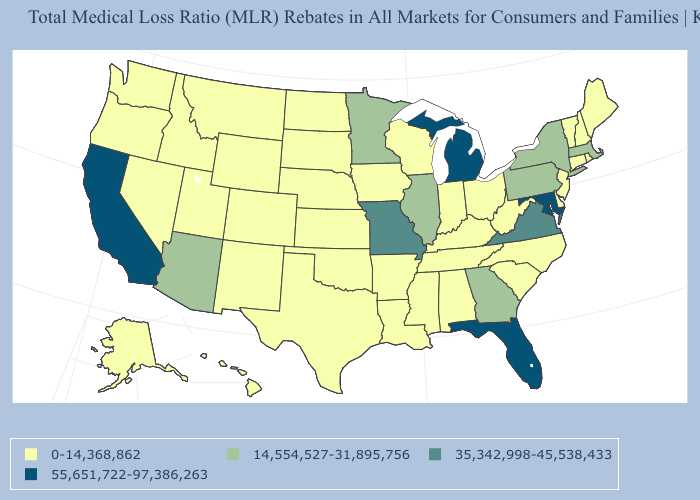Name the states that have a value in the range 0-14,368,862?
Answer briefly. Alabama, Alaska, Arkansas, Colorado, Connecticut, Delaware, Hawaii, Idaho, Indiana, Iowa, Kansas, Kentucky, Louisiana, Maine, Mississippi, Montana, Nebraska, Nevada, New Hampshire, New Jersey, New Mexico, North Carolina, North Dakota, Ohio, Oklahoma, Oregon, Rhode Island, South Carolina, South Dakota, Tennessee, Texas, Utah, Vermont, Washington, West Virginia, Wisconsin, Wyoming. Which states hav the highest value in the Northeast?
Give a very brief answer. Massachusetts, New York, Pennsylvania. What is the value of West Virginia?
Keep it brief. 0-14,368,862. What is the value of Kentucky?
Answer briefly. 0-14,368,862. Name the states that have a value in the range 14,554,527-31,895,756?
Short answer required. Arizona, Georgia, Illinois, Massachusetts, Minnesota, New York, Pennsylvania. What is the value of South Carolina?
Short answer required. 0-14,368,862. Which states have the lowest value in the West?
Quick response, please. Alaska, Colorado, Hawaii, Idaho, Montana, Nevada, New Mexico, Oregon, Utah, Washington, Wyoming. What is the lowest value in the West?
Answer briefly. 0-14,368,862. Does Michigan have the lowest value in the MidWest?
Give a very brief answer. No. What is the highest value in states that border Nebraska?
Write a very short answer. 35,342,998-45,538,433. Does Arkansas have a lower value than New Hampshire?
Give a very brief answer. No. Which states have the highest value in the USA?
Be succinct. California, Florida, Maryland, Michigan. Does New Hampshire have the highest value in the Northeast?
Give a very brief answer. No. Which states have the lowest value in the South?
Write a very short answer. Alabama, Arkansas, Delaware, Kentucky, Louisiana, Mississippi, North Carolina, Oklahoma, South Carolina, Tennessee, Texas, West Virginia. Which states hav the highest value in the South?
Short answer required. Florida, Maryland. 